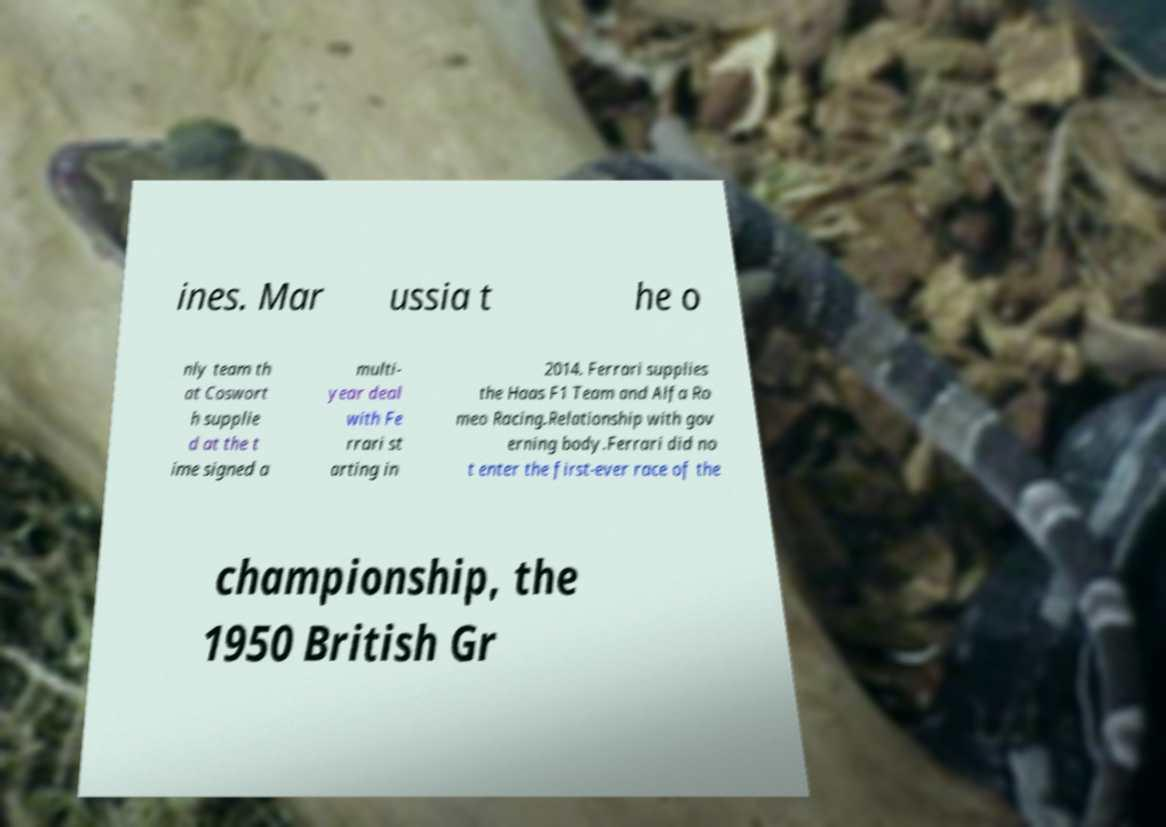For documentation purposes, I need the text within this image transcribed. Could you provide that? ines. Mar ussia t he o nly team th at Coswort h supplie d at the t ime signed a multi- year deal with Fe rrari st arting in 2014. Ferrari supplies the Haas F1 Team and Alfa Ro meo Racing.Relationship with gov erning body.Ferrari did no t enter the first-ever race of the championship, the 1950 British Gr 